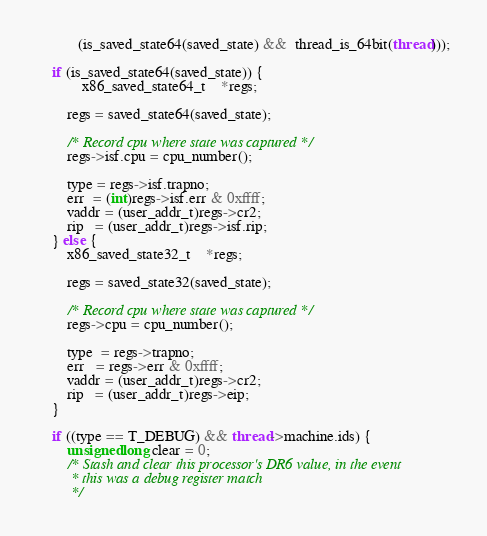<code> <loc_0><loc_0><loc_500><loc_500><_C_>	       (is_saved_state64(saved_state) &&  thread_is_64bit(thread)));

	if (is_saved_state64(saved_state)) {
	        x86_saved_state64_t	*regs;

		regs = saved_state64(saved_state);

		/* Record cpu where state was captured */
		regs->isf.cpu = cpu_number();

		type = regs->isf.trapno;
		err  = (int)regs->isf.err & 0xffff;
		vaddr = (user_addr_t)regs->cr2;
		rip   = (user_addr_t)regs->isf.rip;
	} else {
		x86_saved_state32_t	*regs;

		regs = saved_state32(saved_state);

		/* Record cpu where state was captured */
		regs->cpu = cpu_number();

		type  = regs->trapno;
		err   = regs->err & 0xffff;
		vaddr = (user_addr_t)regs->cr2;
		rip   = (user_addr_t)regs->eip;
	}

	if ((type == T_DEBUG) && thread->machine.ids) {
		unsigned long clear = 0;
		/* Stash and clear this processor's DR6 value, in the event
		 * this was a debug register match
		 */</code> 